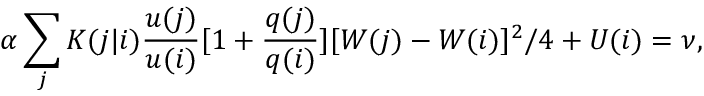Convert formula to latex. <formula><loc_0><loc_0><loc_500><loc_500>\alpha \sum _ { j } K ( j | i ) \frac { u ( j ) } { u ( i ) } [ 1 + \frac { q ( j ) } { q ( i ) } ] [ W ( j ) - W ( i ) ] ^ { 2 } / 4 + U ( i ) = \nu ,</formula> 